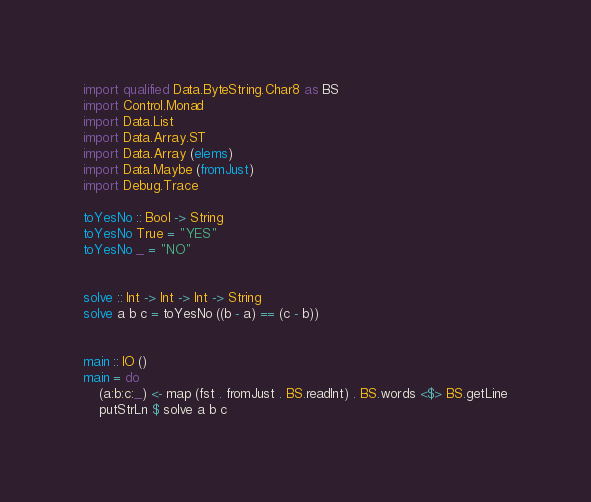Convert code to text. <code><loc_0><loc_0><loc_500><loc_500><_Haskell_>import qualified Data.ByteString.Char8 as BS
import Control.Monad
import Data.List
import Data.Array.ST
import Data.Array (elems)
import Data.Maybe (fromJust)
import Debug.Trace

toYesNo :: Bool -> String
toYesNo True = "YES"
toYesNo _ = "NO"


solve :: Int -> Int -> Int -> String
solve a b c = toYesNo ((b - a) == (c - b))


main :: IO ()
main = do
    (a:b:c:_) <- map (fst . fromJust . BS.readInt) . BS.words <$> BS.getLine
    putStrLn $ solve a b c

</code> 